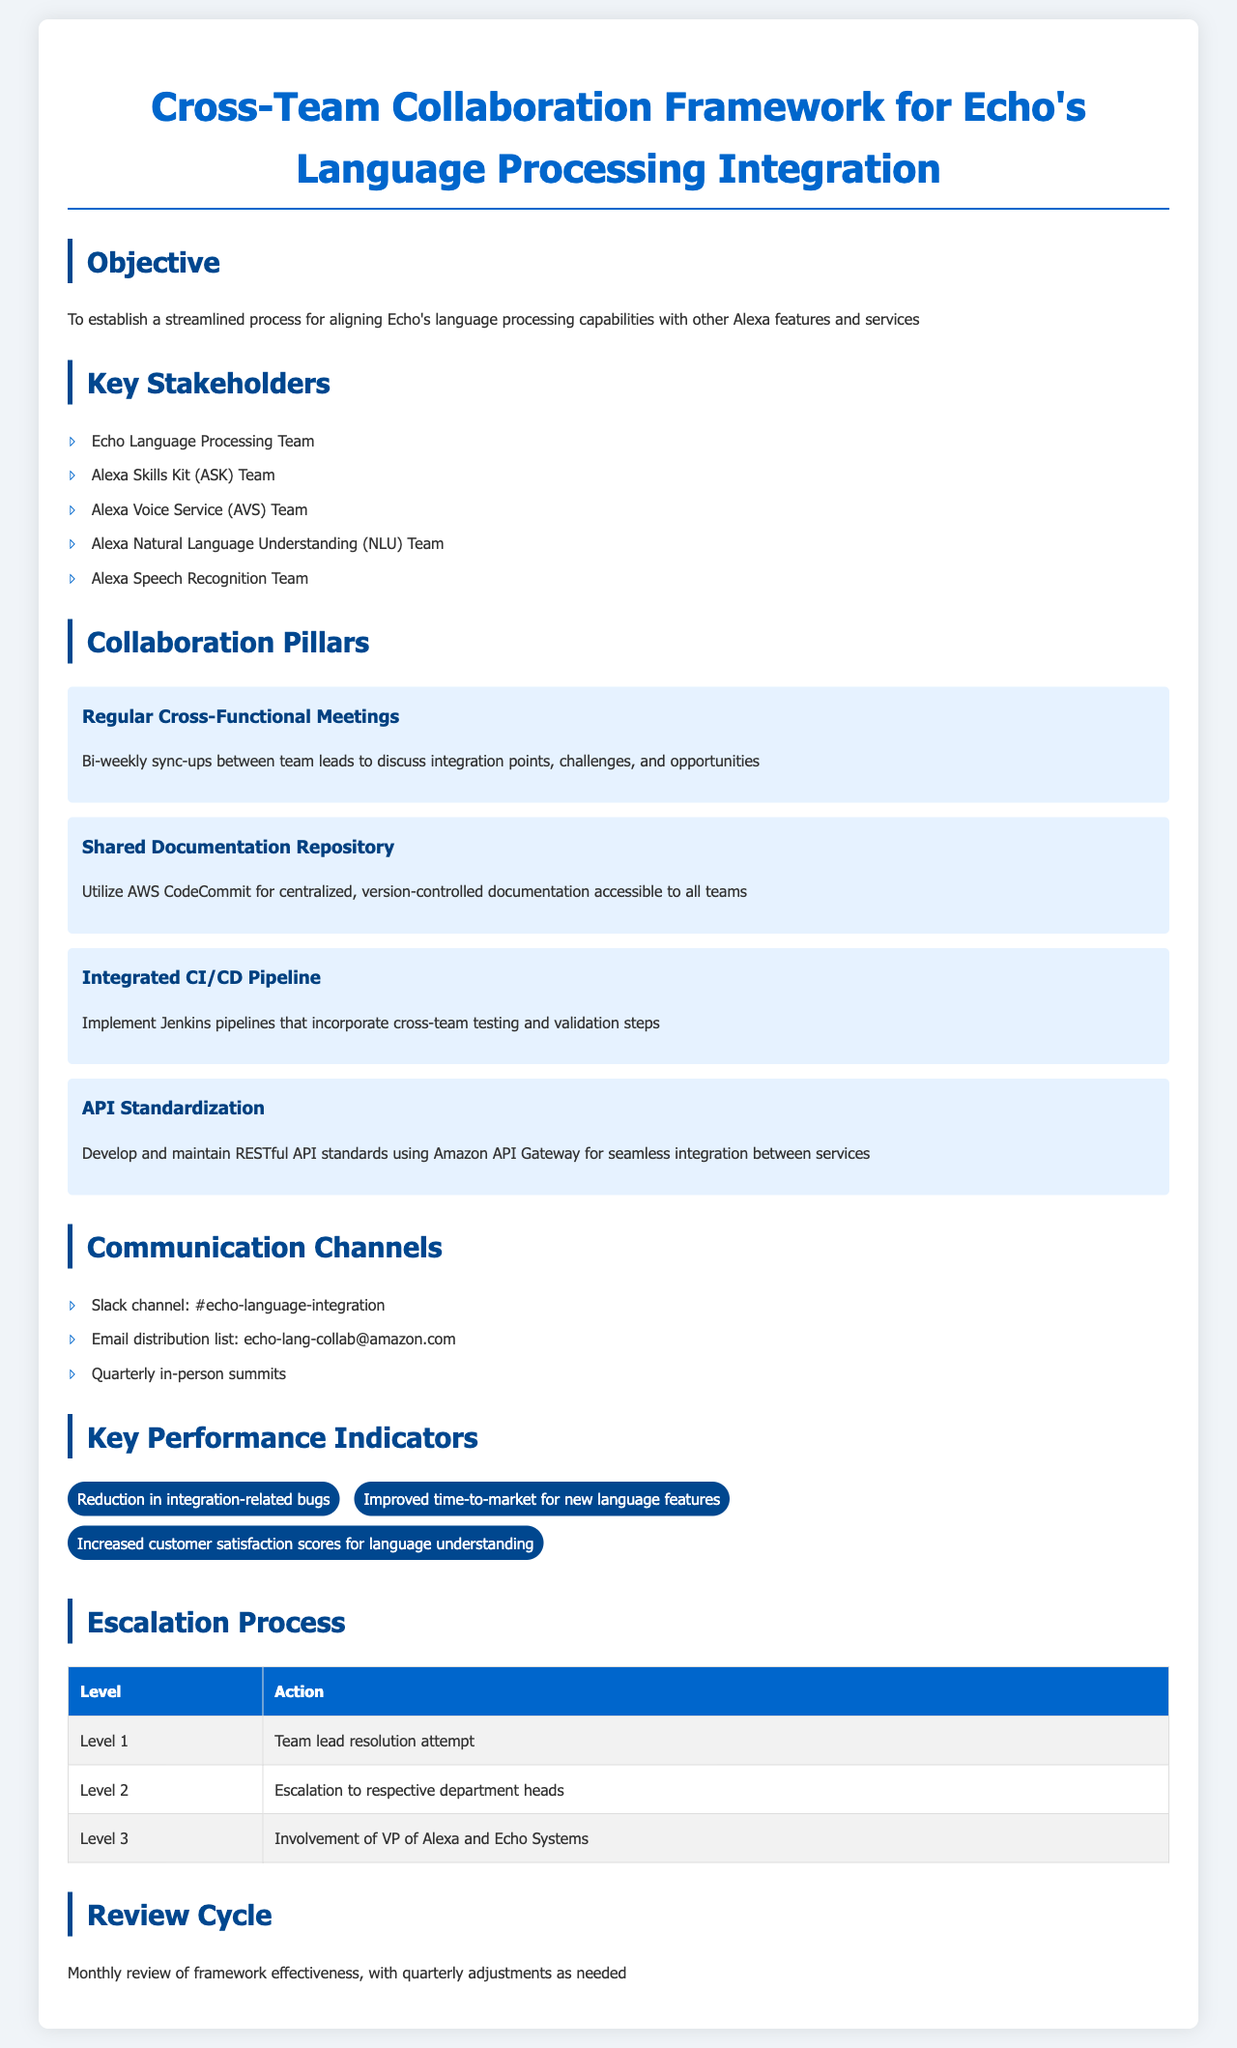What is the objective of the framework? The objective is to establish a streamlined process for aligning Echo's language processing capabilities with other Alexa features and services.
Answer: To establish a streamlined process for aligning Echo's language processing capabilities with other Alexa features and services Who are the key stakeholders listed in the document? The key stakeholders include various teams involved in language processing and related services.
Answer: Echo Language Processing Team, Alexa Skills Kit Team, Alexa Voice Service Team, Alexa Natural Language Understanding Team, Alexa Speech Recognition Team How often are the cross-functional meetings held? The document specifies the frequency of meetings to ensure ongoing collaboration and communication.
Answer: Bi-weekly What communication channels are mentioned for collaboration? The communication channels listed facilitate interaction among the teams.
Answer: Slack channel, Email distribution list, Quarterly in-person summits What is the top-level escalation process action? The document outlines specific actions to be taken at various levels of escalation.
Answer: Team lead resolution attempt How is success measured according to the Key Performance Indicators? The document lists criteria that reflect the effectiveness of the collaboration framework.
Answer: Reduction in integration-related bugs, Improved time-to-market for new language features, Increased customer satisfaction scores for language understanding What is the review cycle frequency for the framework's effectiveness? The review cycle is mentioned to ensure the framework remains effective and relevant.
Answer: Monthly What are the collaboration pillars outlined in the document? The pillars are core principles that guide the collaboration efforts among teams.
Answer: Regular Cross-Functional Meetings, Shared Documentation Repository, Integrated CI/CD Pipeline, API Standardization 